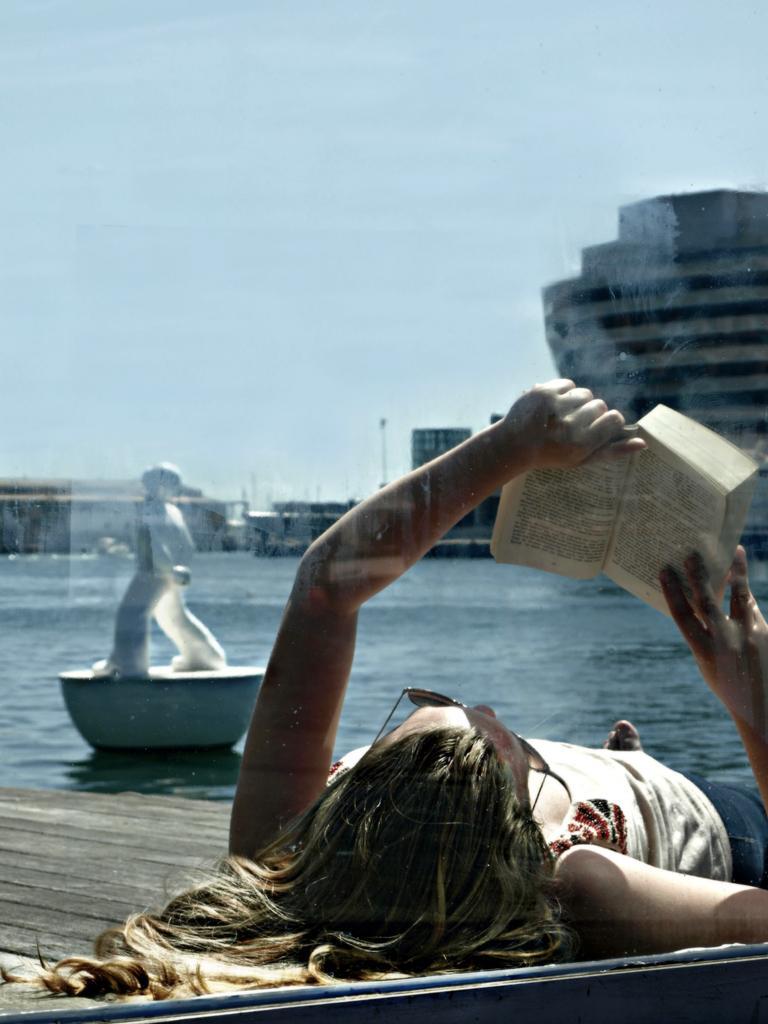Could you give a brief overview of what you see in this image? In the front of the image I can see a woman is laying on the surface and holding a book. In the background there is water, statue, buildings, pole and cloudy sky. 